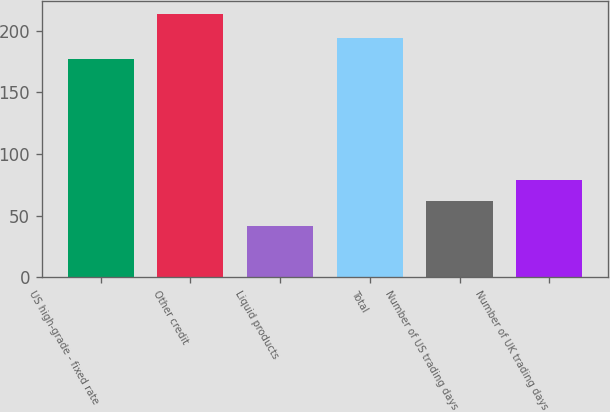<chart> <loc_0><loc_0><loc_500><loc_500><bar_chart><fcel>US high-grade - fixed rate<fcel>Other credit<fcel>Liquid products<fcel>Total<fcel>Number of US trading days<fcel>Number of UK trading days<nl><fcel>177<fcel>213<fcel>42<fcel>194.1<fcel>62<fcel>79.1<nl></chart> 